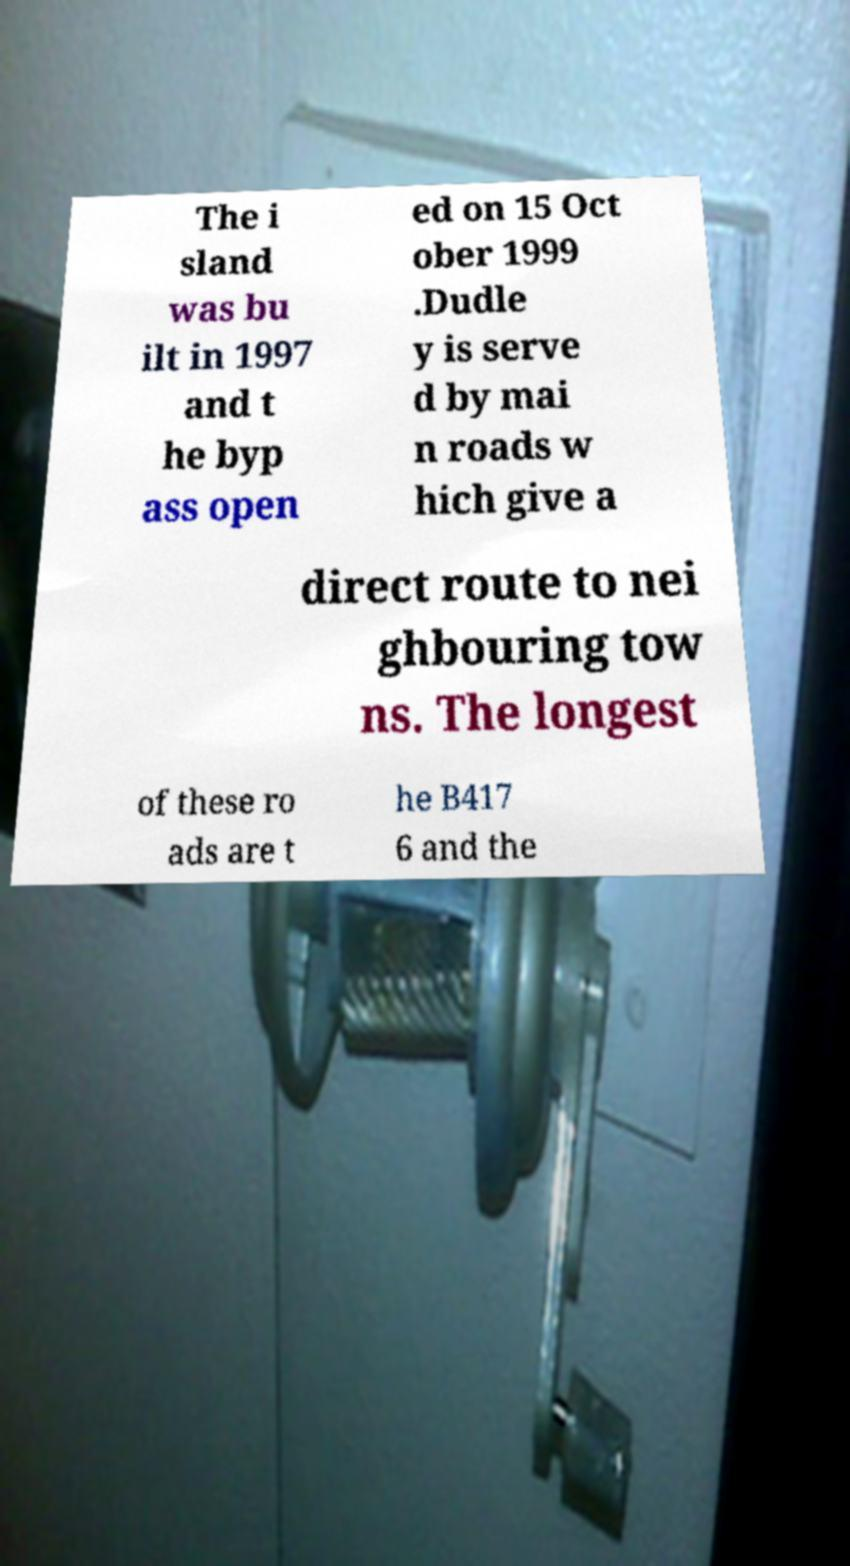I need the written content from this picture converted into text. Can you do that? The i sland was bu ilt in 1997 and t he byp ass open ed on 15 Oct ober 1999 .Dudle y is serve d by mai n roads w hich give a direct route to nei ghbouring tow ns. The longest of these ro ads are t he B417 6 and the 